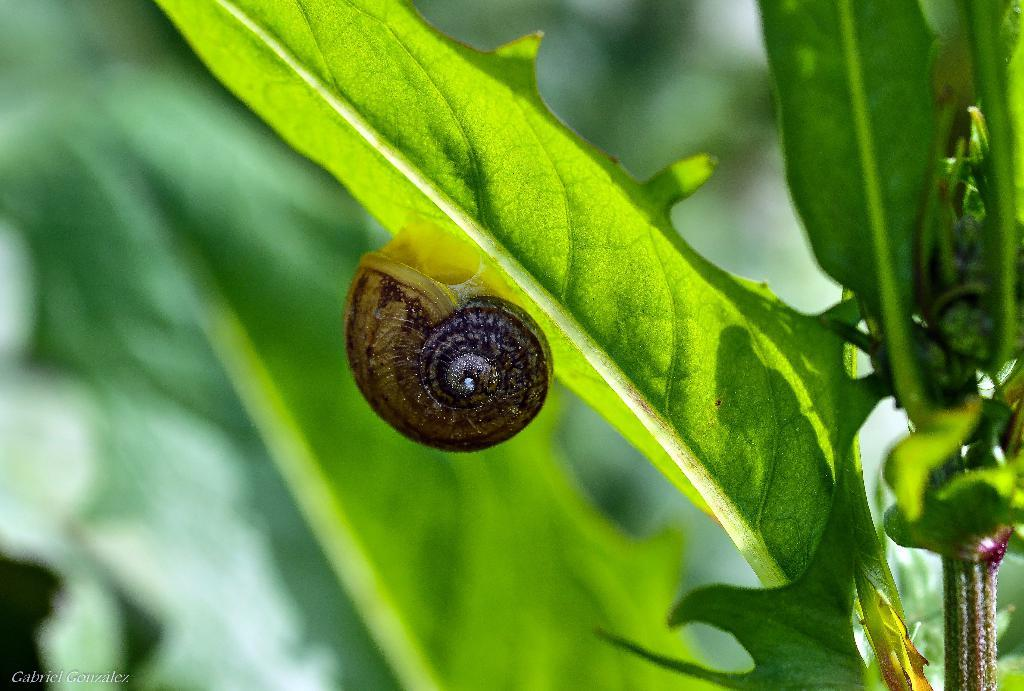What is the main subject of the image? There is a snail in the image. Where is the snail located? The snail is on a leaf. Can you describe the background of the image? The background of the image is blurred. What type of jelly can be seen on the canvas in the image? There is no jelly or canvas present in the image; it features a snail on a leaf with a blurred background. 